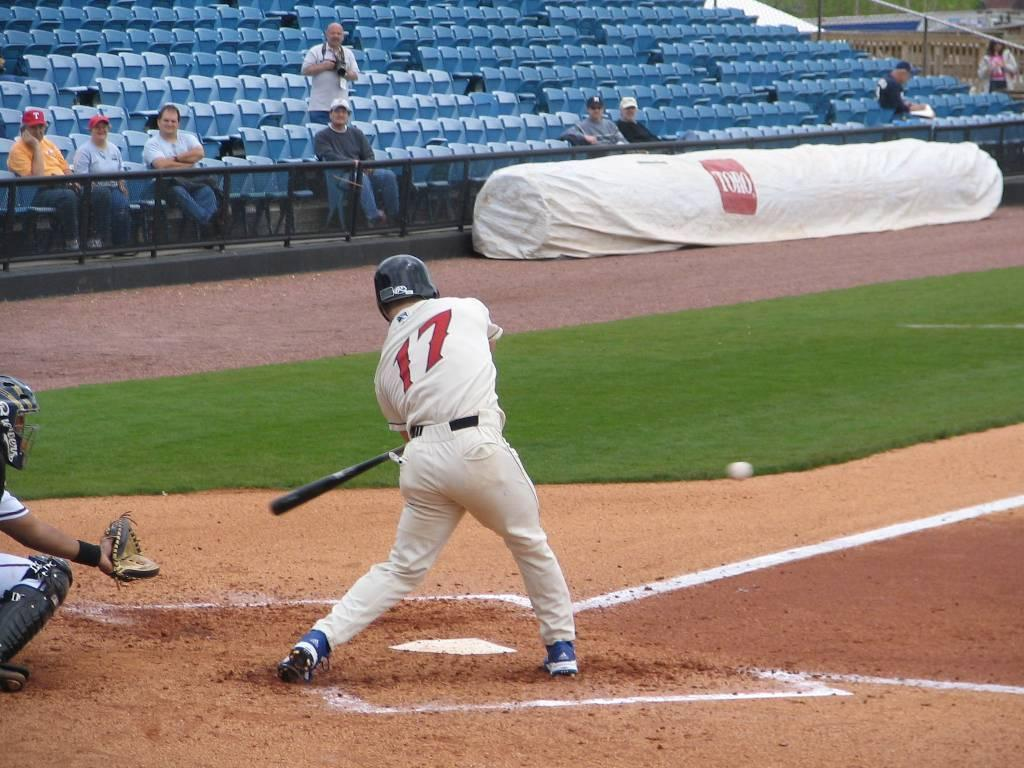<image>
Summarize the visual content of the image. A batter hitting a ball while wearing a number 17 jersey . 